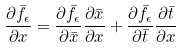<formula> <loc_0><loc_0><loc_500><loc_500>\frac { \partial \bar { f } _ { \epsilon } } { \partial x } = \frac { \partial \bar { f } _ { \epsilon } } { \partial \bar { x } } \frac { \partial \bar { x } } { \partial x } + \frac { \partial \bar { f } _ { \epsilon } } { \partial \bar { t } } \frac { \partial \bar { t } } { \partial x }</formula> 